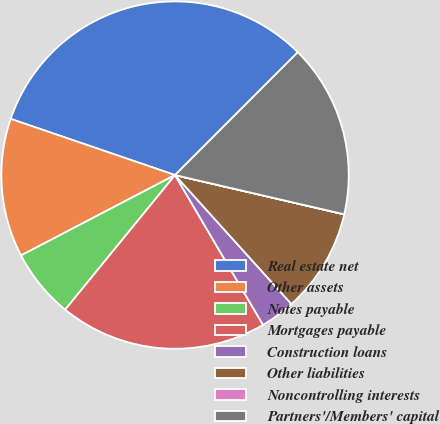Convert chart to OTSL. <chart><loc_0><loc_0><loc_500><loc_500><pie_chart><fcel>Real estate net<fcel>Other assets<fcel>Notes payable<fcel>Mortgages payable<fcel>Construction loans<fcel>Other liabilities<fcel>Noncontrolling interests<fcel>Partners'/Members' capital<nl><fcel>32.25%<fcel>12.9%<fcel>6.45%<fcel>19.35%<fcel>3.23%<fcel>9.68%<fcel>0.01%<fcel>16.13%<nl></chart> 